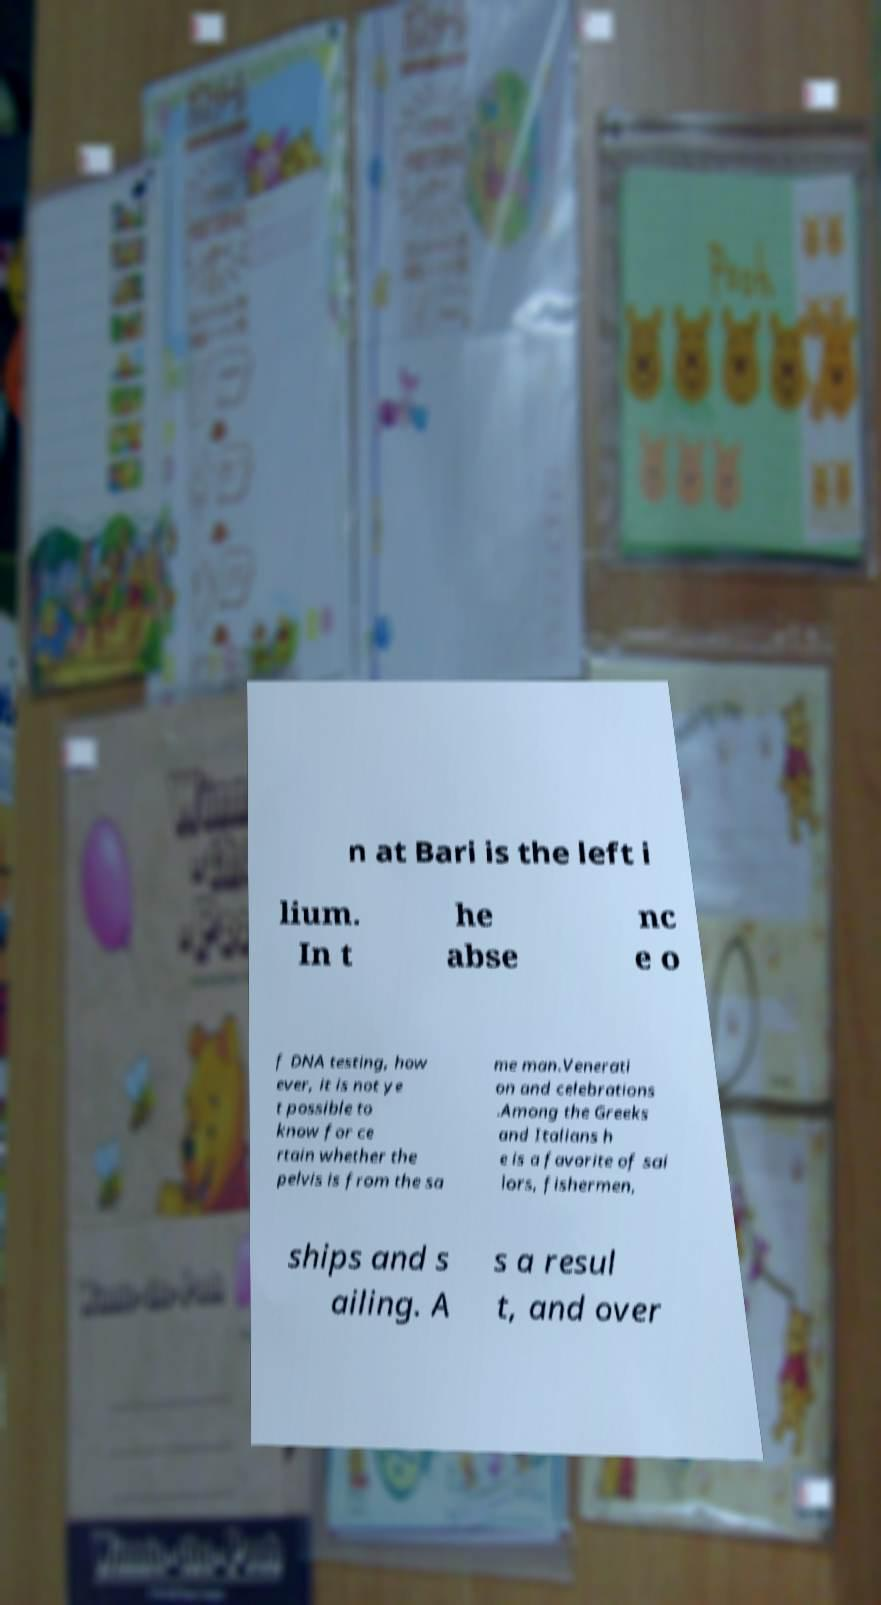Please identify and transcribe the text found in this image. n at Bari is the left i lium. In t he abse nc e o f DNA testing, how ever, it is not ye t possible to know for ce rtain whether the pelvis is from the sa me man.Venerati on and celebrations .Among the Greeks and Italians h e is a favorite of sai lors, fishermen, ships and s ailing. A s a resul t, and over 